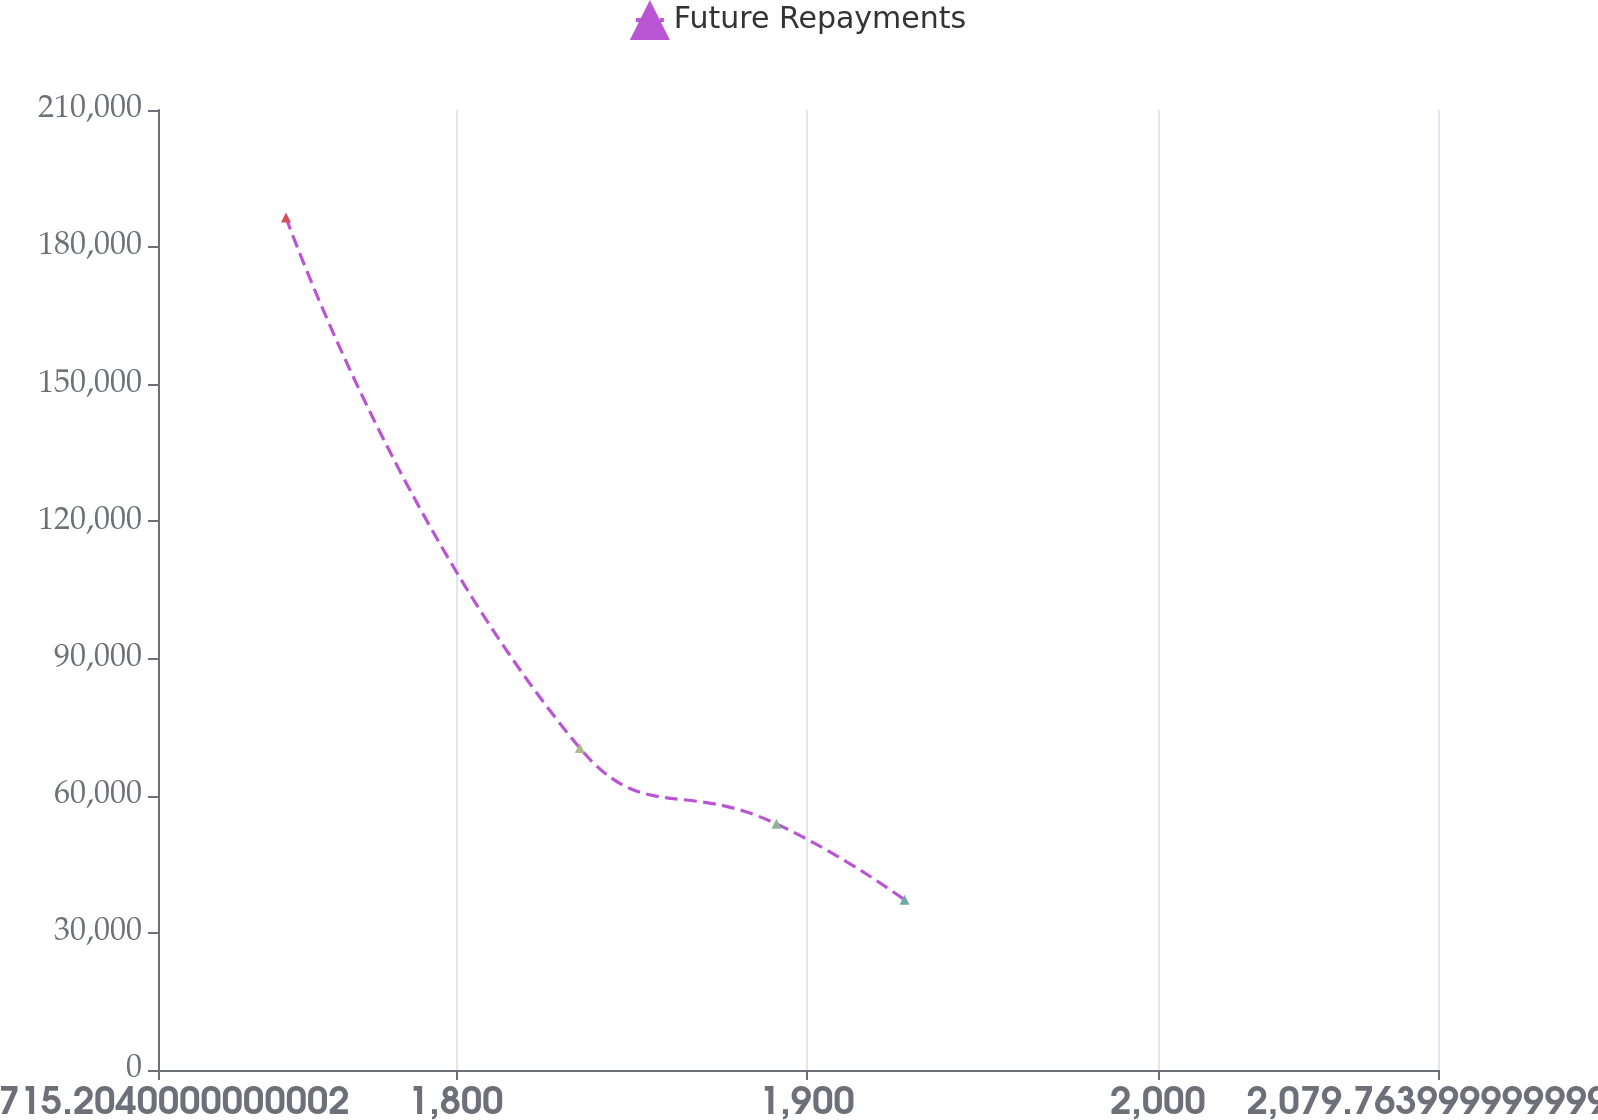Convert chart to OTSL. <chart><loc_0><loc_0><loc_500><loc_500><line_chart><ecel><fcel>Future Repayments<nl><fcel>1751.66<fcel>186487<nl><fcel>1835.34<fcel>70432.9<nl><fcel>1891.35<fcel>53840.4<nl><fcel>1927.81<fcel>37247.8<nl><fcel>2116.22<fcel>20561<nl></chart> 